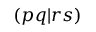Convert formula to latex. <formula><loc_0><loc_0><loc_500><loc_500>( p q | r s )</formula> 